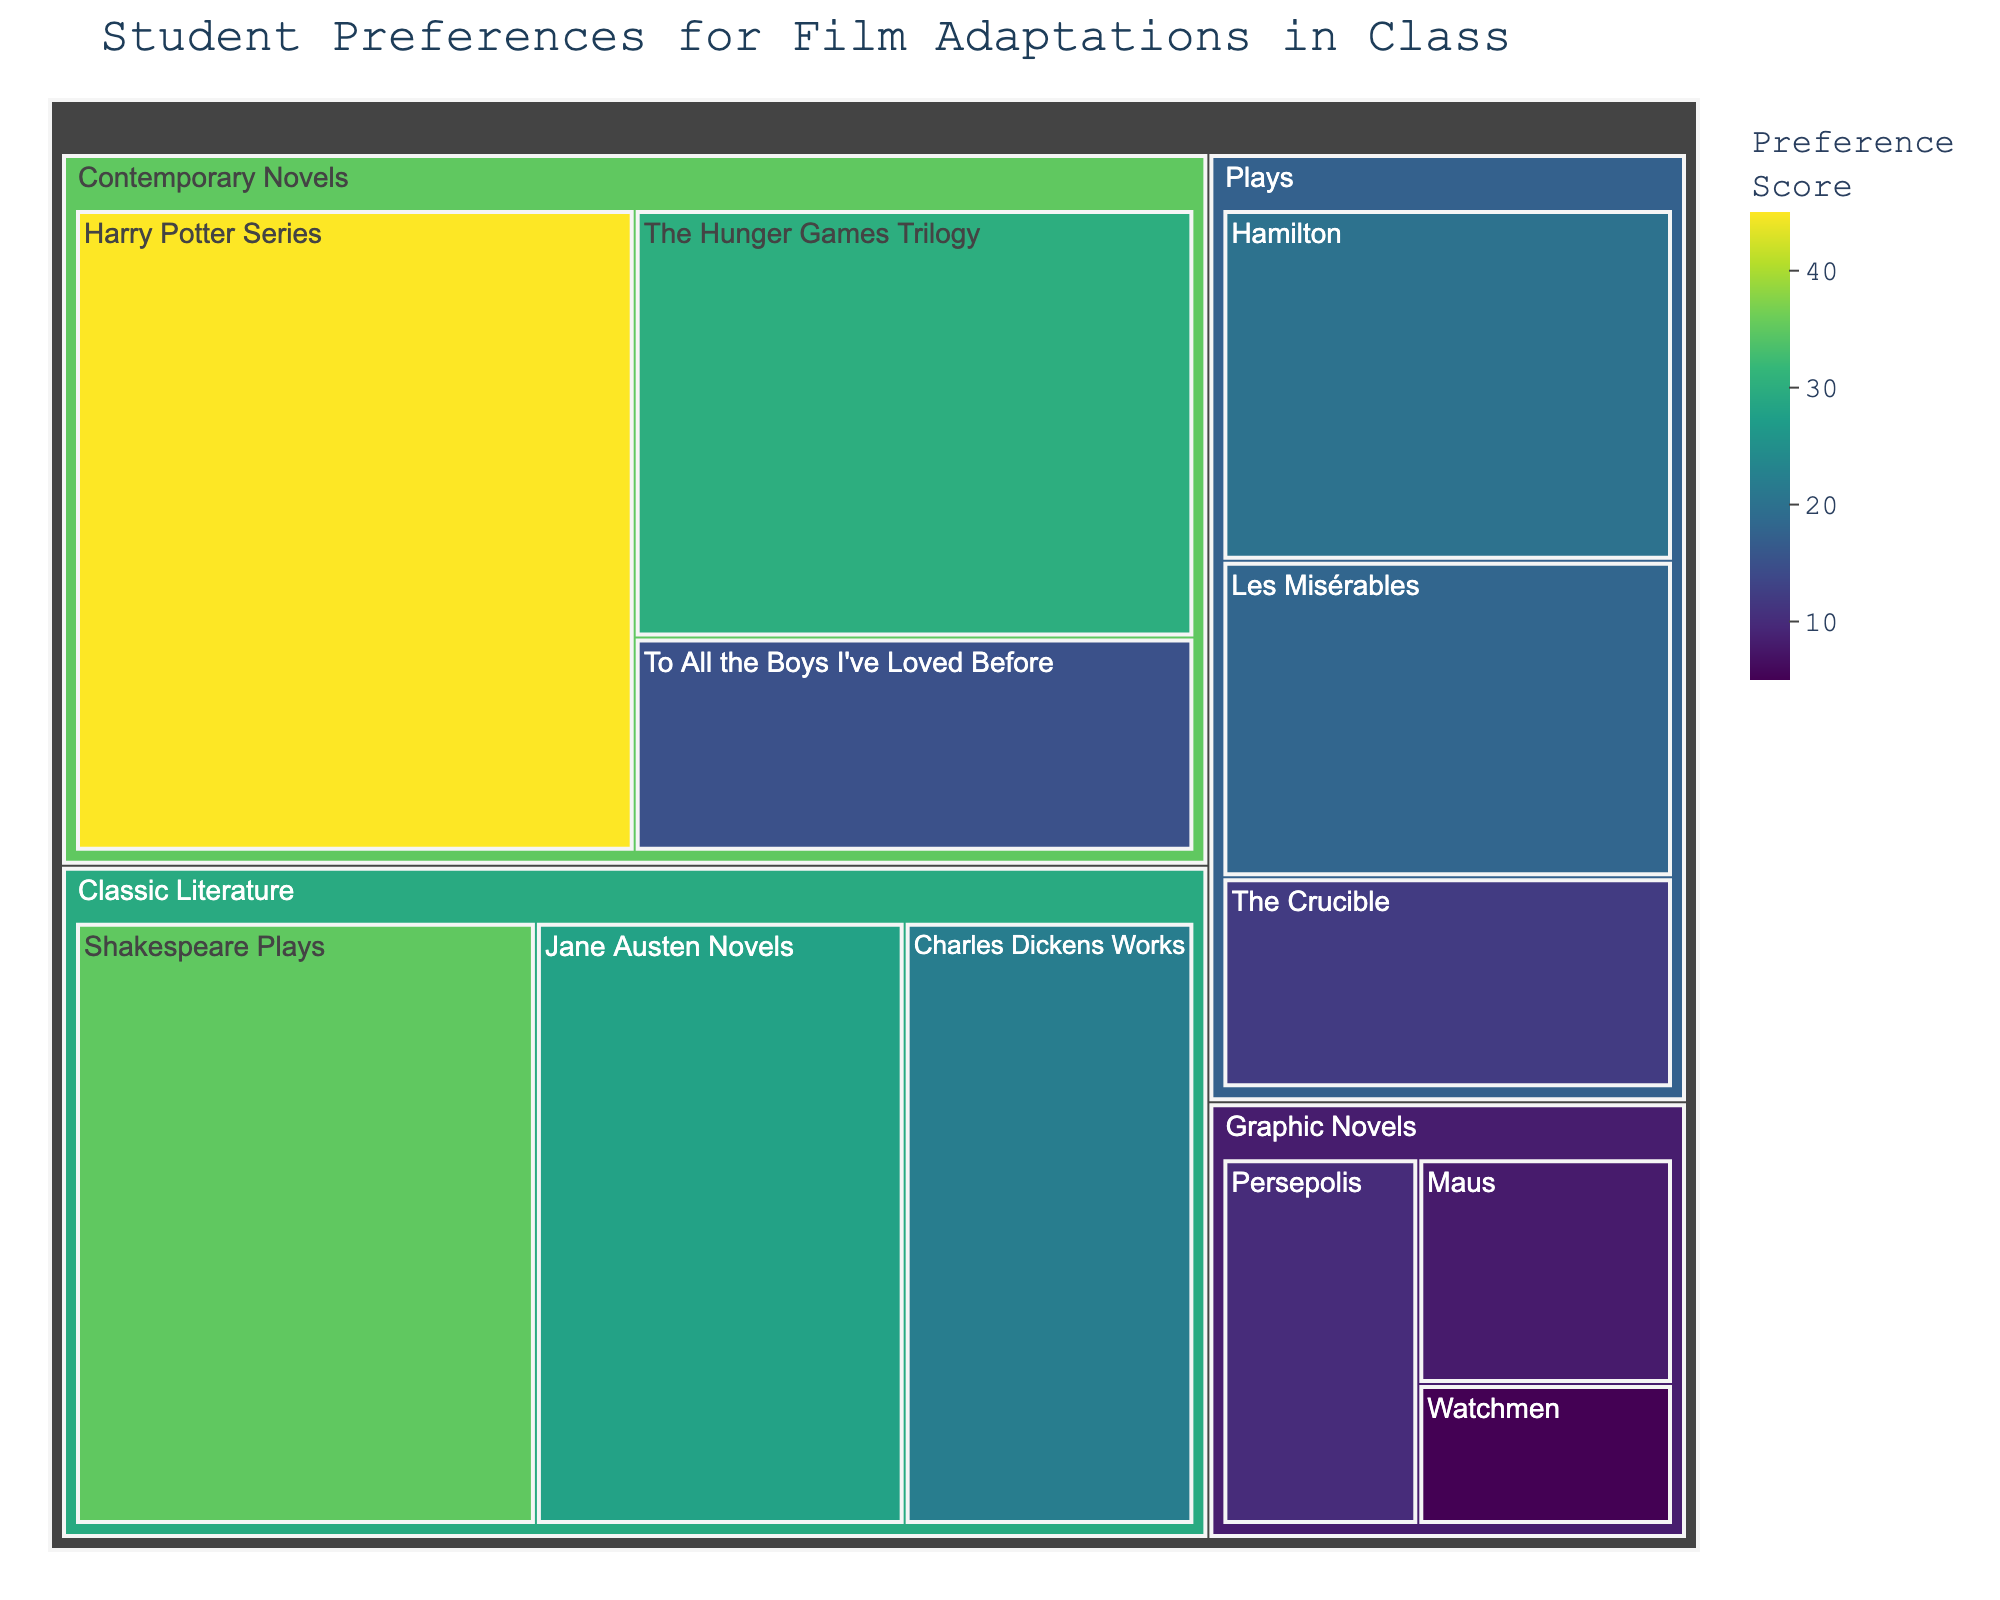Which film adaptation category has the highest preference score overall? To find the category with the highest overall preference score, sum the values for each category. The totals are: Classic Literature (35 + 28 + 22 = 85), Contemporary Novels (45 + 30 + 15 = 90), Plays (20 + 18 + 12 = 50), and Graphic Novels (10 + 8 + 5 = 23). Comparing these sums, Contemporary Novels has the highest score.
Answer: Contemporary Novels What is the total preference score for Graphic Novels? Add the values of all subcategories in Graphic Novels: Persepolis (10), Maus (8), and Watchmen (5). The total is 10 + 8 + 5.
Answer: 23 Which subcategory has the lowest preference score? To determine the subcategory with the lowest preference score, examine the values of each subcategory. The lowest value is 5, which corresponds to Watchmen in the Graphic Novels category.
Answer: Watchmen Compare the preference scores of Shakespeare Plays and Hamilton. Which one is higher? The preference score for Shakespeare Plays is 35, while for Hamilton it is 20. Comparing these, Shakespeare Plays has the higher score.
Answer: Shakespeare Plays How much greater is the preference score for The Hunger Games Trilogy compared to The Crucible? The score for The Hunger Games Trilogy is 30, and The Crucible is 12. Subtract the lower score from the higher score: 30 - 12.
Answer: 18 What is the average preference score for subcategories within the Plays category? To find the average, add the values of the subcategories in the Plays category: 20 (Hamilton) + 18 (Les Misérables) + 12 (The Crucible) = 50. Then, divide by the number of subcategories, which is 3: 50 / 3.
Answer: 16.67 Which subcategory within the Classic Literature category has the highest preference score? Within Classic Literature, the subcategories are Shakespeare Plays (35), Jane Austen Novels (28), and Charles Dickens Works (22). The highest score is 35.
Answer: Shakespeare Plays Is the preference score for Harry Potter Series greater than the combined score of Maus and Watchmen? The preference score for Harry Potter Series is 45. The combined score of Maus and Watchmen is 8 + 5 = 13. Since 45 is greater than 13, the answer is yes.
Answer: Yes What is the combined preference score of the top two subcategories in preference score? Identify the top two subcategories in terms of preference score: Harry Potter Series (45) and Shakespeare Plays (35). Add these scores: 45 + 35.
Answer: 80 Which category has the smallest range of preference scores among its subcategories? Calculate the range (difference between highest and lowest scores) for each category: Classic Literature (35 - 22 = 13), Contemporary Novels (45 - 15 = 30), Plays (20 - 12 = 8), and Graphic Novels (10 - 5 = 5). The smallest range is in Graphic Novels, which is 5.
Answer: Graphic Novels 